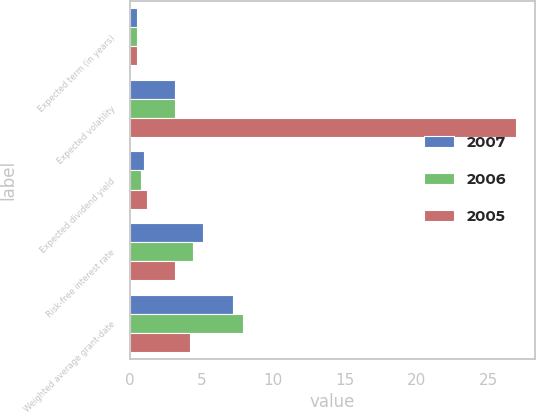Convert chart to OTSL. <chart><loc_0><loc_0><loc_500><loc_500><stacked_bar_chart><ecel><fcel>Expected term (in years)<fcel>Expected volatility<fcel>Expected dividend yield<fcel>Risk-free interest rate<fcel>Weighted average grant-date<nl><fcel>2007<fcel>0.5<fcel>3.15<fcel>1<fcel>5.09<fcel>7.2<nl><fcel>2006<fcel>0.5<fcel>3.15<fcel>0.75<fcel>4.38<fcel>7.91<nl><fcel>2005<fcel>0.5<fcel>26.93<fcel>1.16<fcel>3.15<fcel>4.15<nl></chart> 